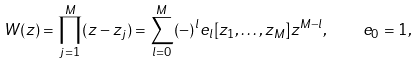Convert formula to latex. <formula><loc_0><loc_0><loc_500><loc_500>W ( z ) = \prod ^ { M } _ { j = 1 } ( z - z _ { j } ) = \sum ^ { M } _ { l = 0 } ( - ) ^ { l } e _ { l } [ z _ { 1 } , \dots , z _ { M } ] z ^ { M - l } , \quad e _ { 0 } = 1 ,</formula> 